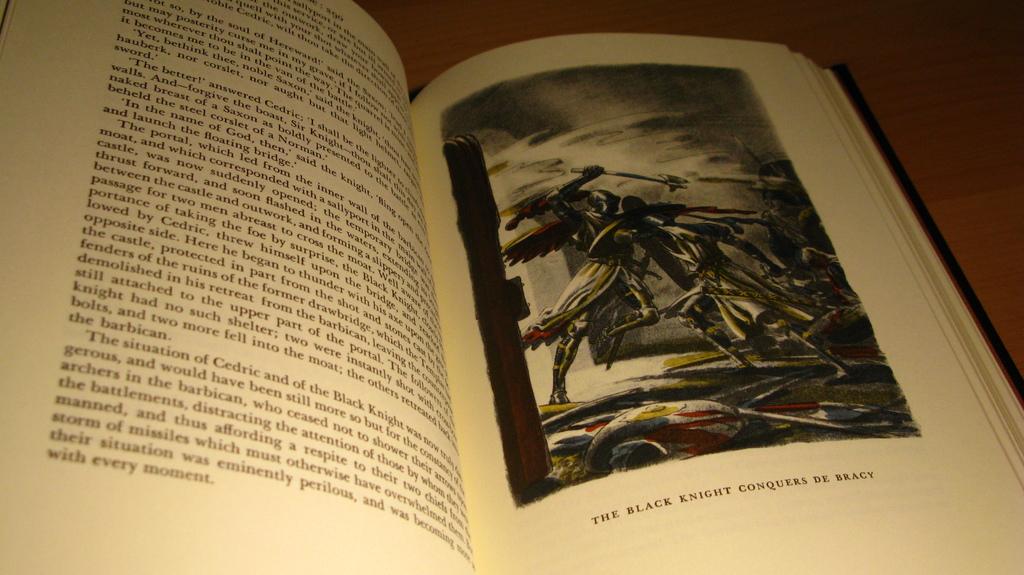What is the caption of the picture?
Ensure brevity in your answer.  The black knight conquers de bracy. What is the color in the caption?
Your response must be concise. Black. 